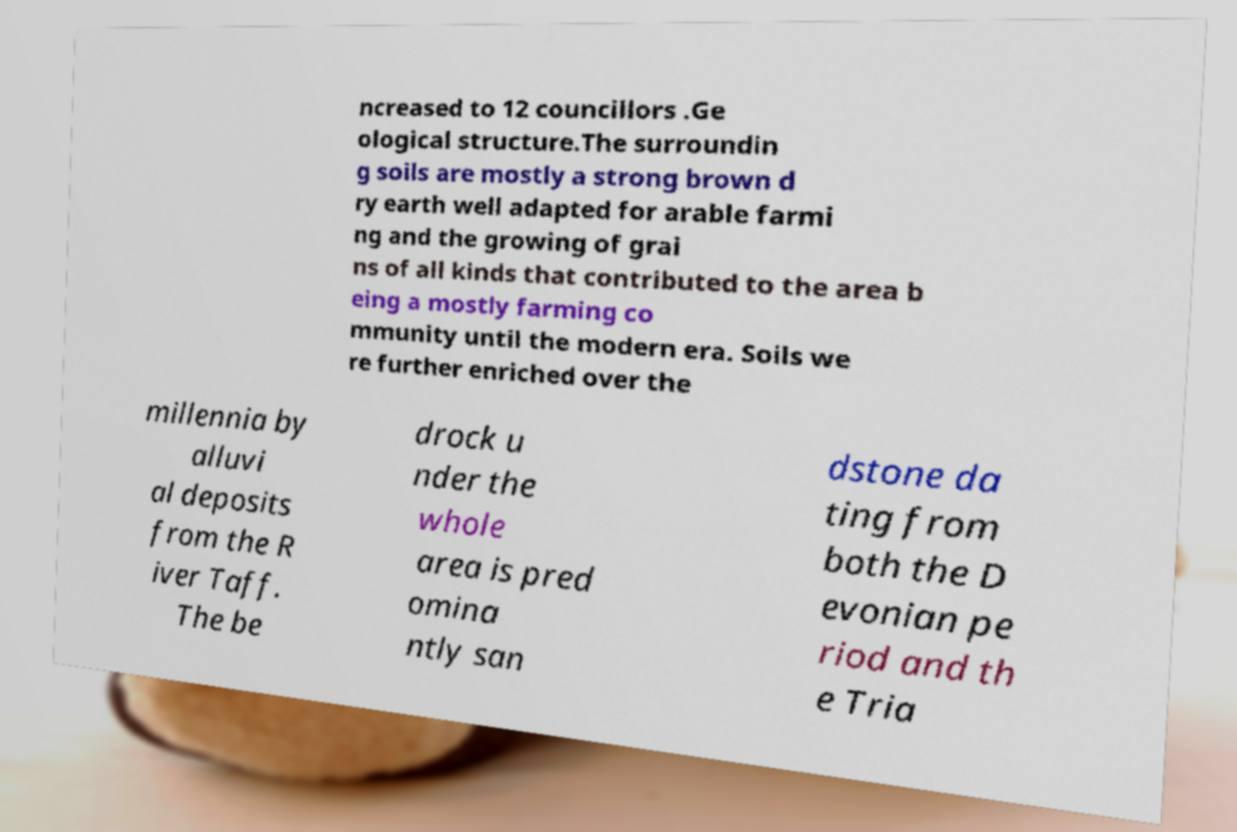There's text embedded in this image that I need extracted. Can you transcribe it verbatim? ncreased to 12 councillors .Ge ological structure.The surroundin g soils are mostly a strong brown d ry earth well adapted for arable farmi ng and the growing of grai ns of all kinds that contributed to the area b eing a mostly farming co mmunity until the modern era. Soils we re further enriched over the millennia by alluvi al deposits from the R iver Taff. The be drock u nder the whole area is pred omina ntly san dstone da ting from both the D evonian pe riod and th e Tria 